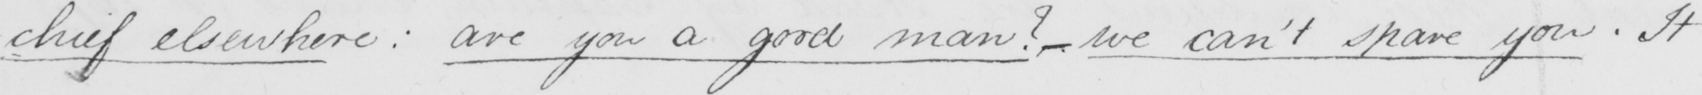Please provide the text content of this handwritten line. -chief elsewhere :  are you a good man ?   _  we can ' t spare you . It 